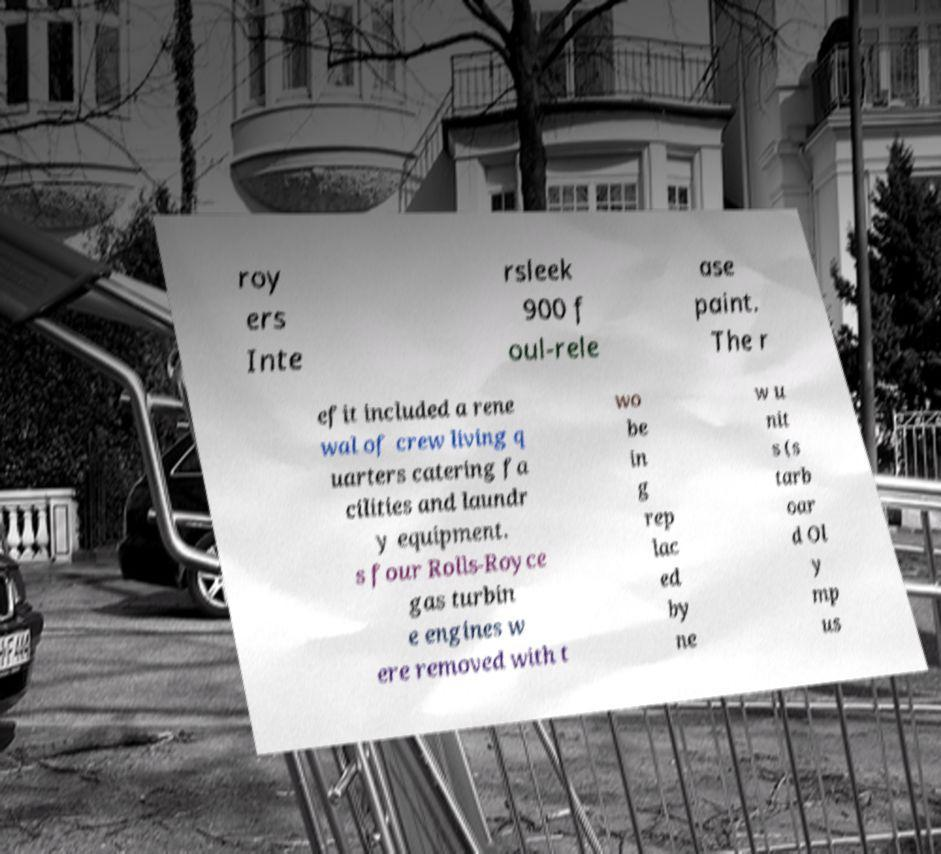There's text embedded in this image that I need extracted. Can you transcribe it verbatim? roy ers Inte rsleek 900 f oul-rele ase paint. The r efit included a rene wal of crew living q uarters catering fa cilities and laundr y equipment. s four Rolls-Royce gas turbin e engines w ere removed with t wo be in g rep lac ed by ne w u nit s (s tarb oar d Ol y mp us 